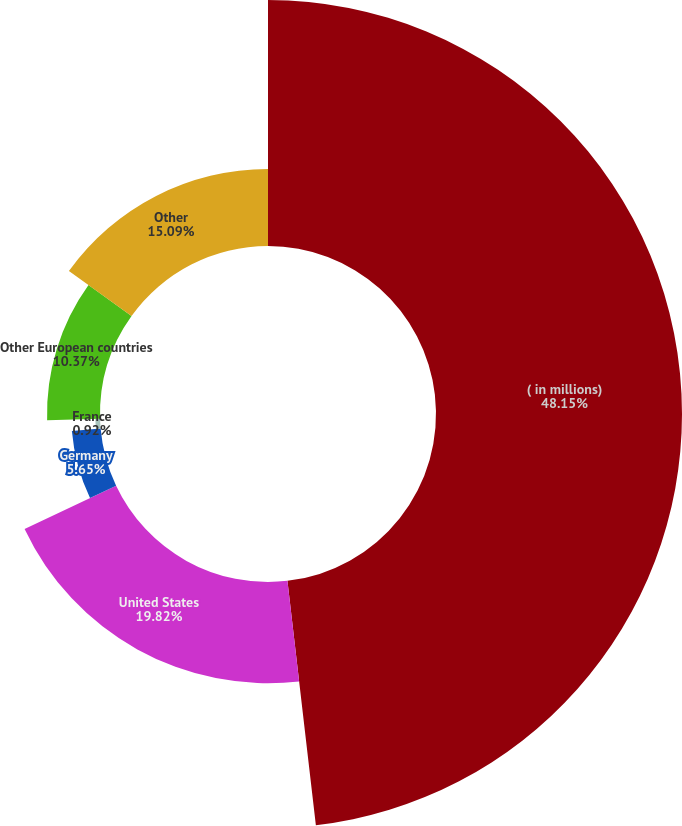Convert chart to OTSL. <chart><loc_0><loc_0><loc_500><loc_500><pie_chart><fcel>( in millions)<fcel>United States<fcel>Germany<fcel>France<fcel>Other European countries<fcel>Other<nl><fcel>48.16%<fcel>19.82%<fcel>5.65%<fcel>0.92%<fcel>10.37%<fcel>15.09%<nl></chart> 